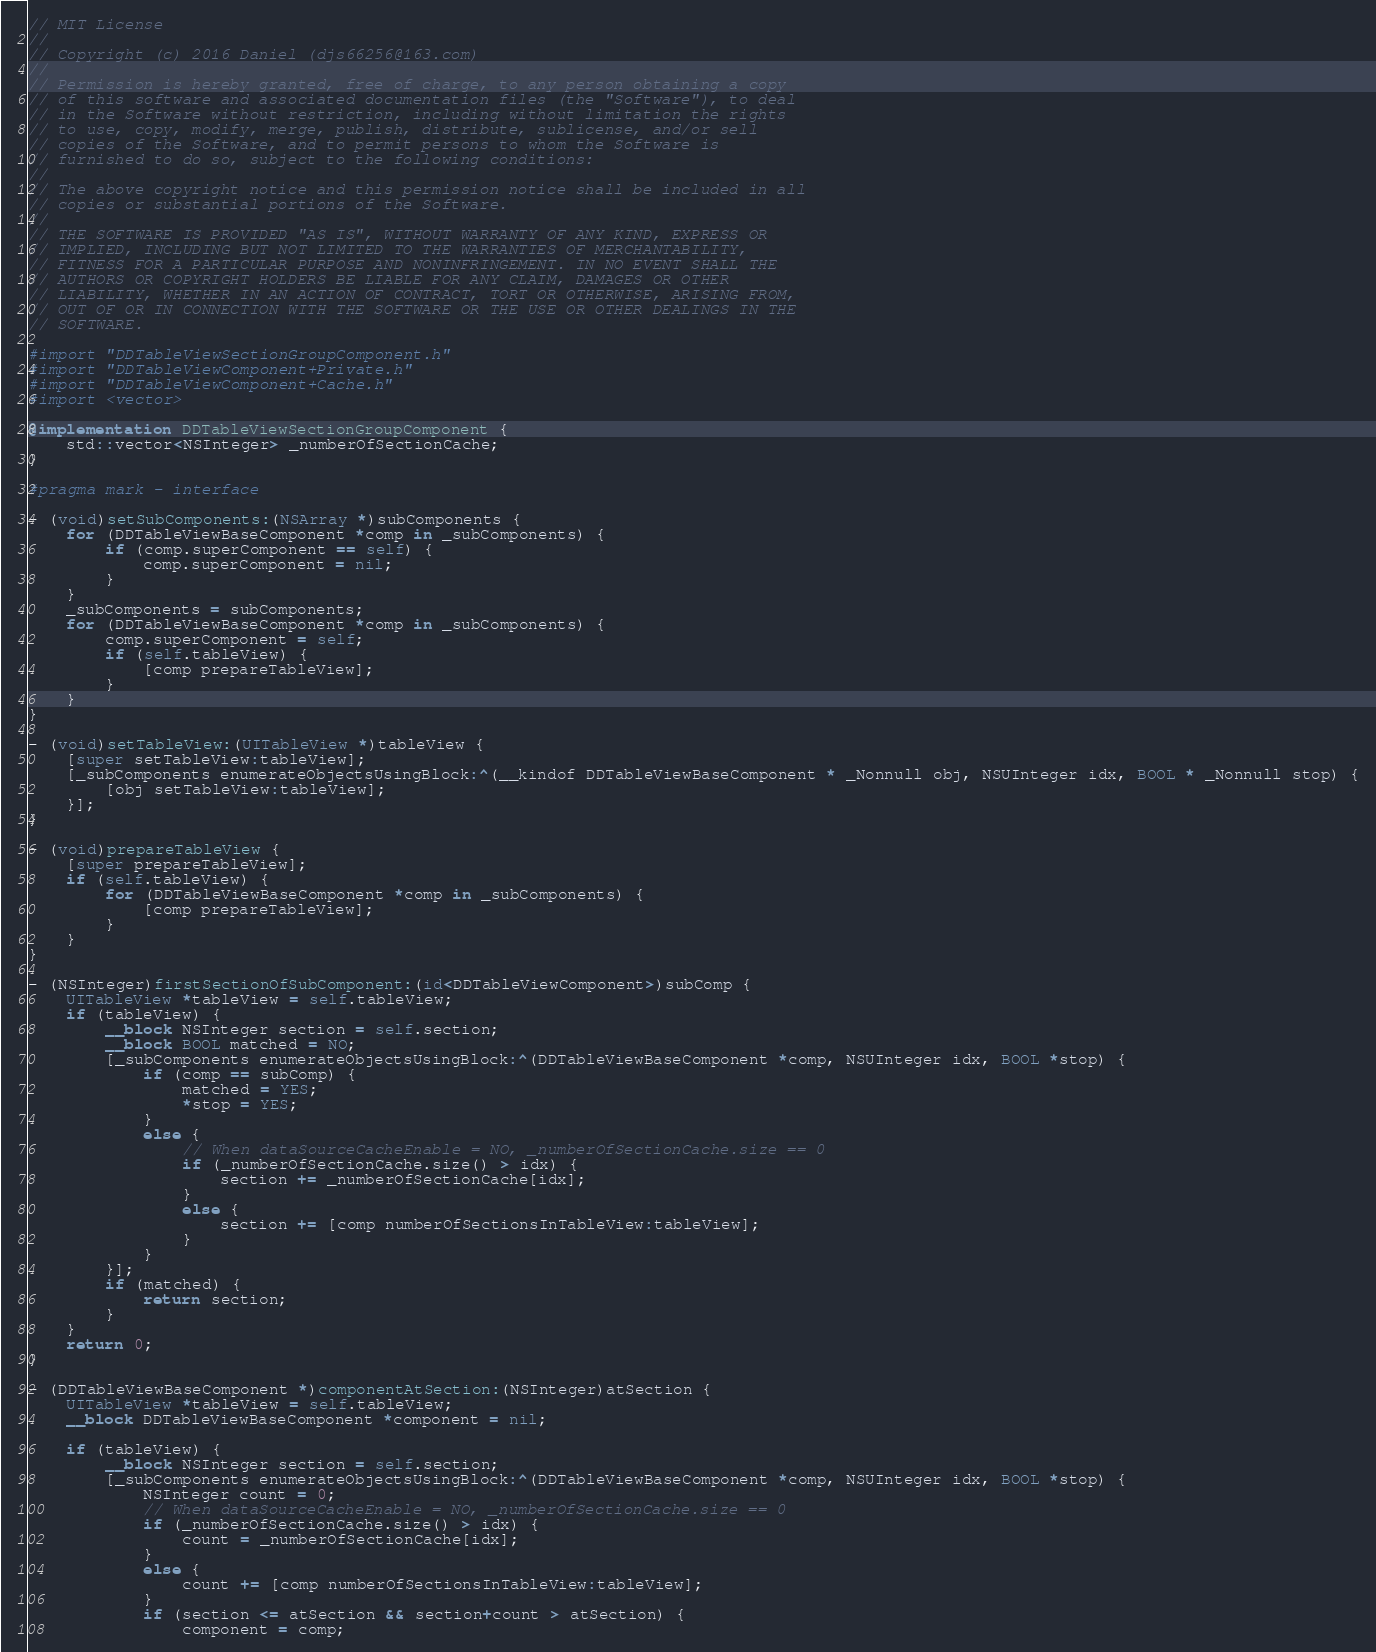Convert code to text. <code><loc_0><loc_0><loc_500><loc_500><_ObjectiveC_>// MIT License
//
// Copyright (c) 2016 Daniel (djs66256@163.com)
//
// Permission is hereby granted, free of charge, to any person obtaining a copy
// of this software and associated documentation files (the "Software"), to deal
// in the Software without restriction, including without limitation the rights
// to use, copy, modify, merge, publish, distribute, sublicense, and/or sell
// copies of the Software, and to permit persons to whom the Software is
// furnished to do so, subject to the following conditions:
//
// The above copyright notice and this permission notice shall be included in all
// copies or substantial portions of the Software.
//
// THE SOFTWARE IS PROVIDED "AS IS", WITHOUT WARRANTY OF ANY KIND, EXPRESS OR
// IMPLIED, INCLUDING BUT NOT LIMITED TO THE WARRANTIES OF MERCHANTABILITY,
// FITNESS FOR A PARTICULAR PURPOSE AND NONINFRINGEMENT. IN NO EVENT SHALL THE
// AUTHORS OR COPYRIGHT HOLDERS BE LIABLE FOR ANY CLAIM, DAMAGES OR OTHER
// LIABILITY, WHETHER IN AN ACTION OF CONTRACT, TORT OR OTHERWISE, ARISING FROM,
// OUT OF OR IN CONNECTION WITH THE SOFTWARE OR THE USE OR OTHER DEALINGS IN THE
// SOFTWARE.

#import "DDTableViewSectionGroupComponent.h"
#import "DDTableViewComponent+Private.h"
#import "DDTableViewComponent+Cache.h"
#import <vector>

@implementation DDTableViewSectionGroupComponent {
    std::vector<NSInteger> _numberOfSectionCache;
}

#pragma mark - interface

- (void)setSubComponents:(NSArray *)subComponents {
    for (DDTableViewBaseComponent *comp in _subComponents) {
        if (comp.superComponent == self) {
            comp.superComponent = nil;
        }
    }
    _subComponents = subComponents;
    for (DDTableViewBaseComponent *comp in _subComponents) {
        comp.superComponent = self;
        if (self.tableView) {
            [comp prepareTableView];
        }
    }
}

- (void)setTableView:(UITableView *)tableView {
    [super setTableView:tableView];
    [_subComponents enumerateObjectsUsingBlock:^(__kindof DDTableViewBaseComponent * _Nonnull obj, NSUInteger idx, BOOL * _Nonnull stop) {
        [obj setTableView:tableView];
    }];
}

- (void)prepareTableView {
    [super prepareTableView];
    if (self.tableView) {
        for (DDTableViewBaseComponent *comp in _subComponents) {
            [comp prepareTableView];
        }
    }
}

- (NSInteger)firstSectionOfSubComponent:(id<DDTableViewComponent>)subComp {
    UITableView *tableView = self.tableView;
    if (tableView) {
        __block NSInteger section = self.section;
        __block BOOL matched = NO;
        [_subComponents enumerateObjectsUsingBlock:^(DDTableViewBaseComponent *comp, NSUInteger idx, BOOL *stop) {
            if (comp == subComp) {
                matched = YES;
                *stop = YES;
            }
            else {
                // When dataSourceCacheEnable = NO, _numberOfSectionCache.size == 0
                if (_numberOfSectionCache.size() > idx) {
                    section += _numberOfSectionCache[idx];
                }
                else {
                    section += [comp numberOfSectionsInTableView:tableView];
                }
            }
        }];
        if (matched) {
            return section;
        }
    }
    return 0;
}

- (DDTableViewBaseComponent *)componentAtSection:(NSInteger)atSection {
    UITableView *tableView = self.tableView;
    __block DDTableViewBaseComponent *component = nil;

    if (tableView) {
        __block NSInteger section = self.section;
        [_subComponents enumerateObjectsUsingBlock:^(DDTableViewBaseComponent *comp, NSUInteger idx, BOOL *stop) {
            NSInteger count = 0;
            // When dataSourceCacheEnable = NO, _numberOfSectionCache.size == 0
            if (_numberOfSectionCache.size() > idx) {
                count = _numberOfSectionCache[idx];
            }
            else {
                count += [comp numberOfSectionsInTableView:tableView];
            }
            if (section <= atSection && section+count > atSection) {
                component = comp;</code> 